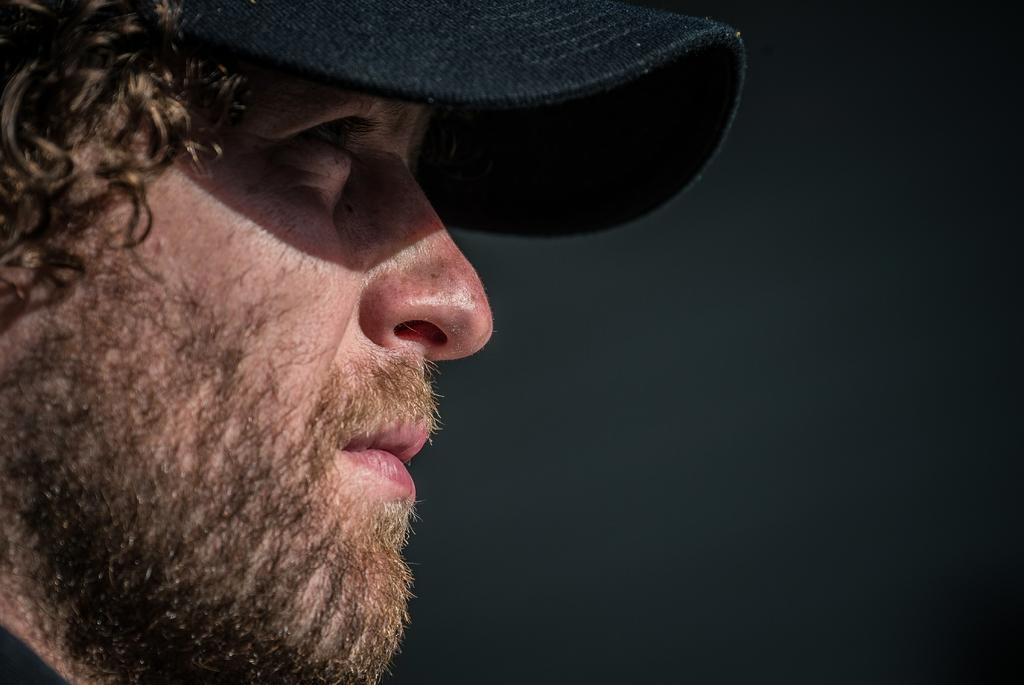What is the main subject of the image? The main subject of the image is a man. What can be seen on the man's head? The man is wearing a black color cap. What type of feather is the man using to eat his breakfast in the image? There is no mention of breakfast or feathers in the image; the man is simply wearing a black color cap. 